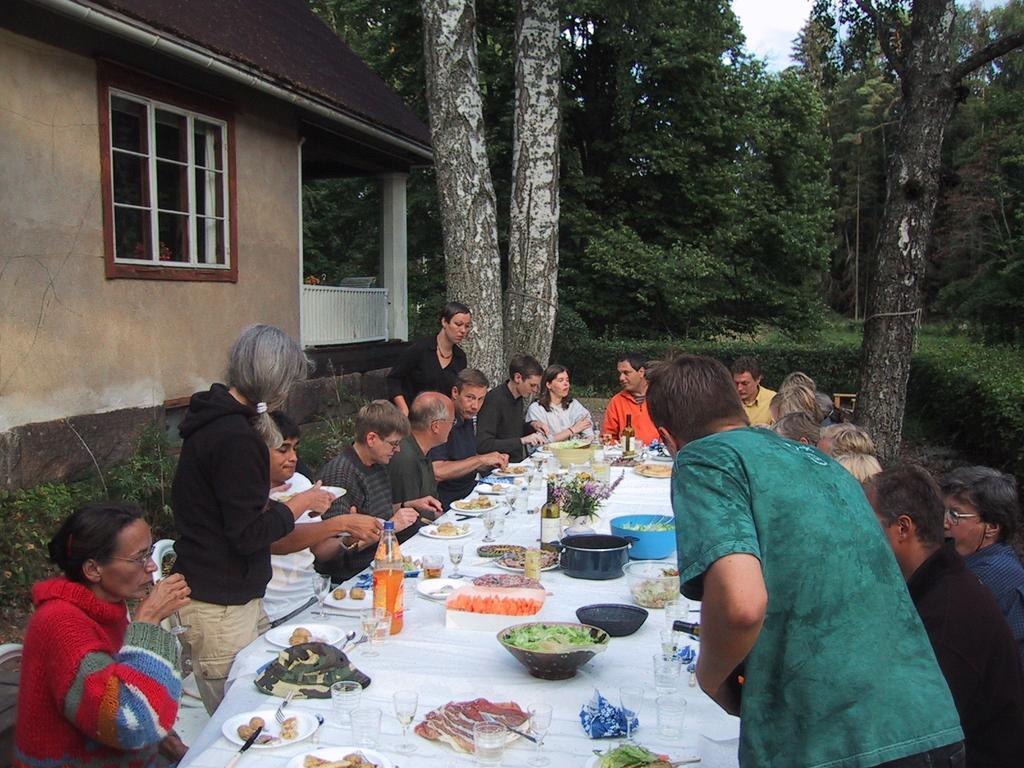How would you summarize this image in a sentence or two? A group of people are sitting around a table and having food. Three people are standing beside them. There are some trees and a house in the background. 